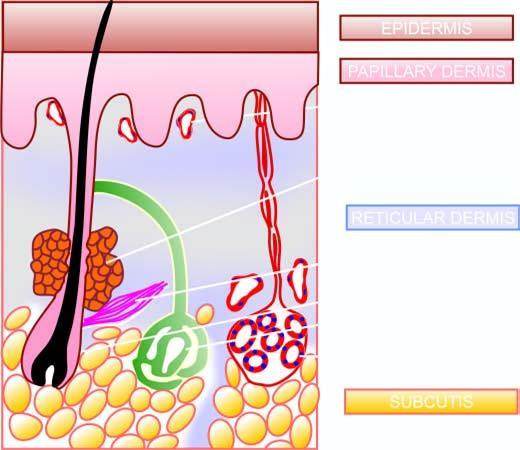re tan areas of haemorrhage identified in a section of the normal skin?
Answer the question using a single word or phrase. No 